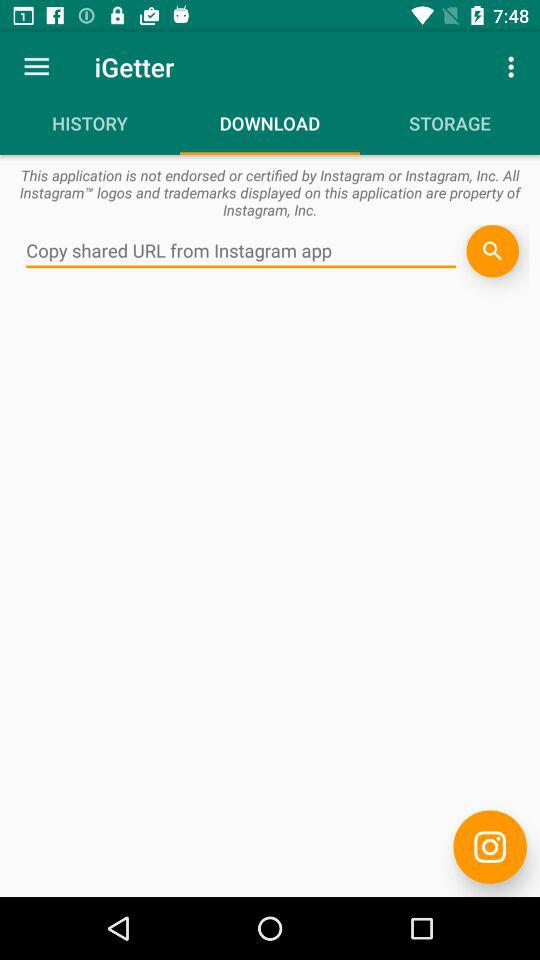Which tab is selected? The selected tab is "DOWNLOAD". 